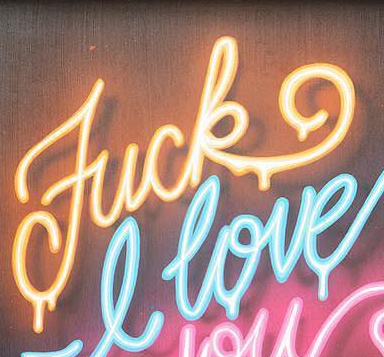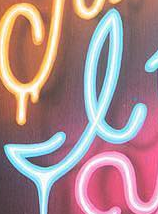What text appears in these images from left to right, separated by a semicolon? Fuck; I 